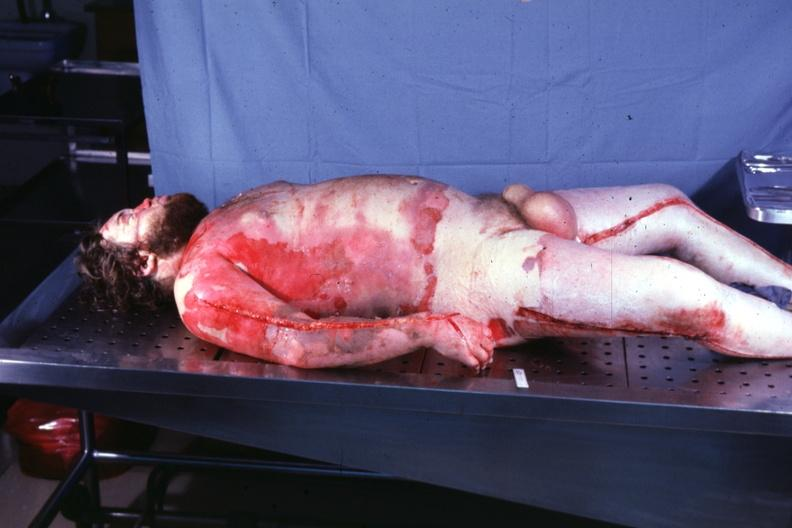does this image show body burns 24 hours prior now anasarca?
Answer the question using a single word or phrase. Yes 